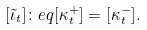<formula> <loc_0><loc_0><loc_500><loc_500>[ \tilde { \iota } _ { t } ] \colon e q [ \kappa ^ { + } _ { t } ] = [ \kappa ^ { - } _ { t } ] .</formula> 